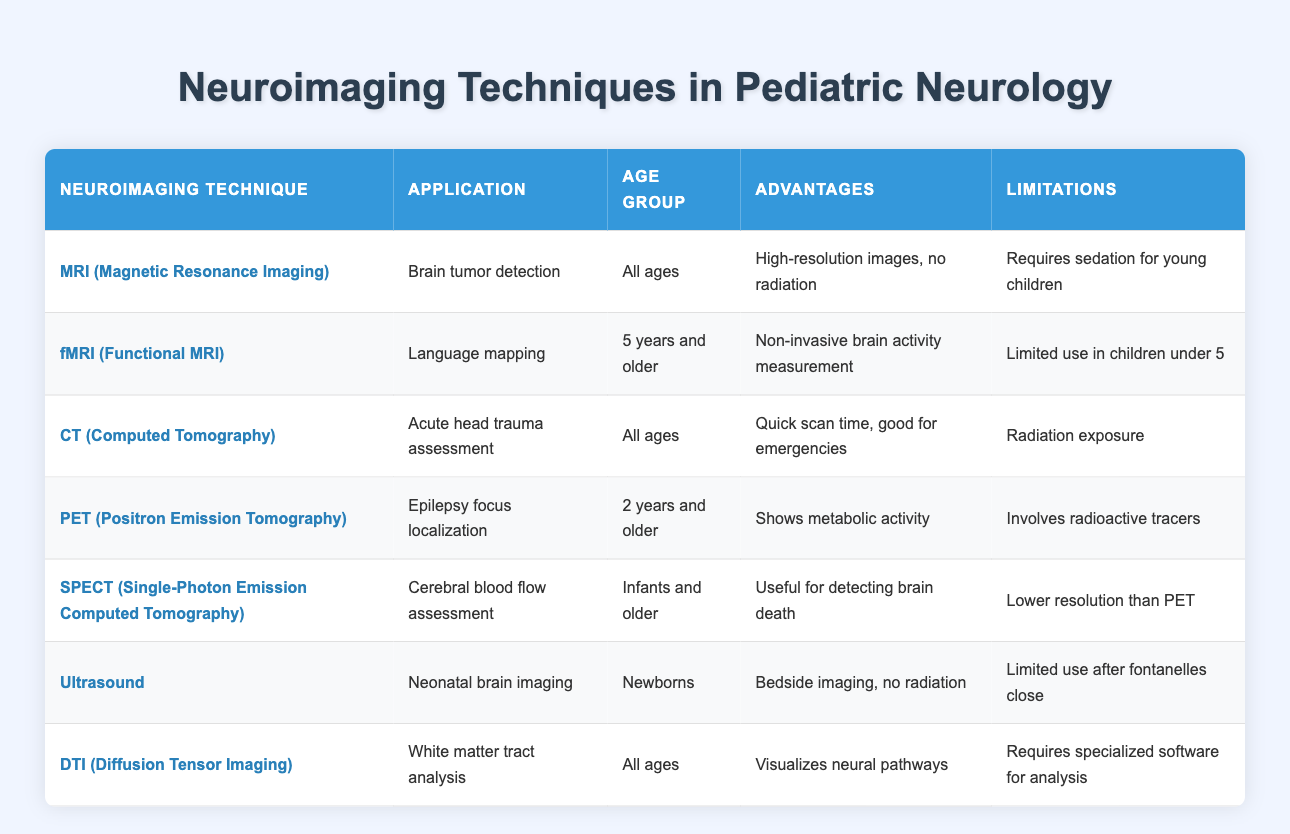What is the primary application of fMRI in pediatric neurology? The table lists the application of fMRI (Functional MRI) as "Language mapping." This information is directly stated in the "Application" column corresponding to fMRI.
Answer: Language mapping Which neuroimaging technique is suitable for newborns? The table indicates that Ultrasound is used for "Neonatal brain imaging" and specifies the age group as "Newborns." This shows that Ultrasound is suitable for this age group.
Answer: Ultrasound How many neuroimaging techniques are applicable for all ages? In the table, both MRI and CT techniques are designated for "All ages." Counting these two entries gives us the number applicable for all ages.
Answer: 2 Is PET non-invasive? The table states that PET (Positron Emission Tomography) involves "radioactive tracers," indicating it is not non-invasive as it uses radioactive substances.
Answer: No What advantages does DTI provide compared to SPECT? DTI (Diffusion Tensor Imaging) offers the advantage of "Visualizes neural pathways," while SPECT has "Lower resolution than PET," implying that DTI's visualization aspect can be seen as a greater strength. Thus, DTI provides advantages in visualizing neural connectivity compared to SPECT's lower resolution.
Answer: DTI visualizes neural pathways What age group can utilize both PET and fMRI? The table notes that PET is suitable for "2 years and older" while fMRI is for "5 years and older." The overlap starts from 5 years, thus the age group that can utilize both is from 5 years and older.
Answer: 5 years and older What is the limitation of CT in pediatric neurology? The limitation of CT (Computed Tomography) listed in the table is "Radiation exposure." This indicates the concern of radiation when using this imaging technique on children.
Answer: Radiation exposure Which neuroimaging technique is quick and good for emergencies? The table mentions CT (Computed Tomography) has the advantage of "Quick scan time, good for emergencies," indicating its efficiency in urgent situations.
Answer: CT What is the difference in the age requirement between fMRI and PET? fMRI is used for children "5 years and older," while PET can be utilized starting from "2 years and older." The difference is therefore 3 years, as fMRI has a higher age requirement than PET.
Answer: 3 years 